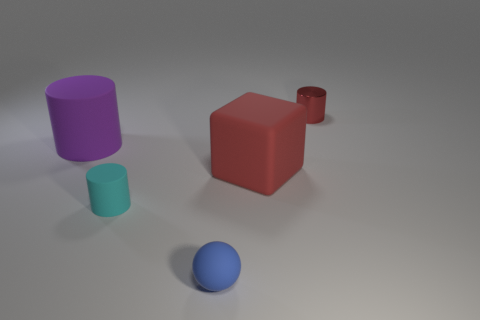Is there any other thing that is made of the same material as the tiny red thing?
Keep it short and to the point. No. How big is the red thing that is in front of the large thing on the left side of the rubber object that is right of the small blue ball?
Offer a very short reply. Large. What number of things are rubber objects right of the rubber ball or cylinders that are in front of the big purple cylinder?
Your response must be concise. 2. What is the shape of the small metal thing?
Offer a terse response. Cylinder. How many other objects are there of the same material as the small red cylinder?
Keep it short and to the point. 0. There is a purple matte object that is the same shape as the small metallic object; what size is it?
Keep it short and to the point. Large. What material is the cylinder that is right of the small rubber object in front of the tiny rubber object that is to the left of the small matte ball made of?
Provide a succinct answer. Metal. Are any small red shiny blocks visible?
Provide a succinct answer. No. Do the block and the tiny cylinder that is in front of the shiny cylinder have the same color?
Provide a short and direct response. No. The large cylinder has what color?
Provide a succinct answer. Purple. 